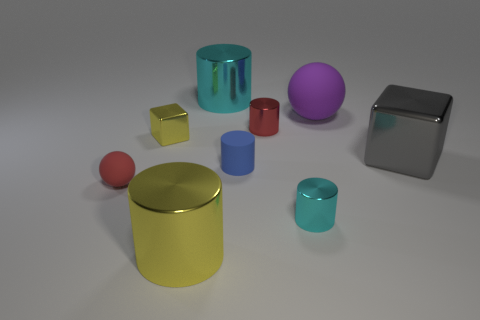What number of yellow cylinders have the same size as the yellow block?
Your response must be concise. 0. Are there fewer yellow metallic cylinders than green things?
Provide a succinct answer. No. There is a yellow metal thing behind the ball that is in front of the tiny blue thing; what shape is it?
Provide a succinct answer. Cube. The other matte object that is the same size as the gray object is what shape?
Offer a very short reply. Sphere. Is there another small gray matte thing of the same shape as the gray object?
Offer a terse response. No. What is the tiny cyan cylinder made of?
Ensure brevity in your answer.  Metal. There is a large yellow shiny object; are there any large gray metallic cubes on the right side of it?
Give a very brief answer. Yes. There is a large gray metal cube that is behind the small cyan cylinder; how many tiny red things are behind it?
Provide a succinct answer. 1. There is a ball that is the same size as the gray metallic thing; what material is it?
Offer a very short reply. Rubber. How many other things are there of the same material as the tiny red sphere?
Offer a terse response. 2. 